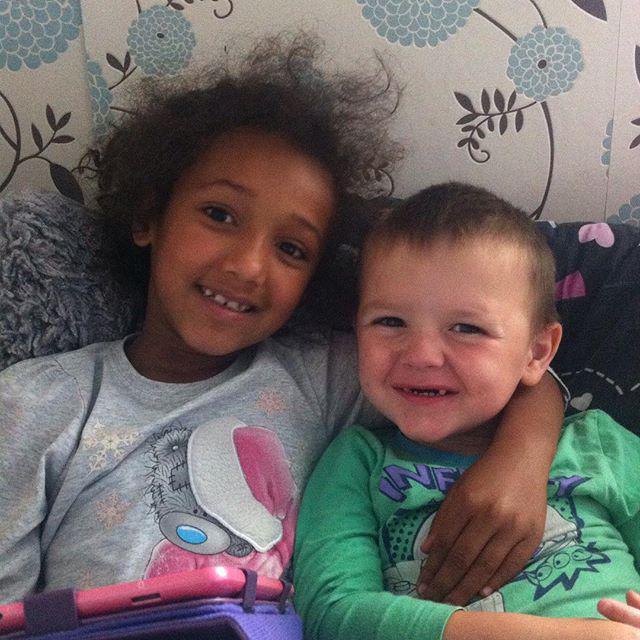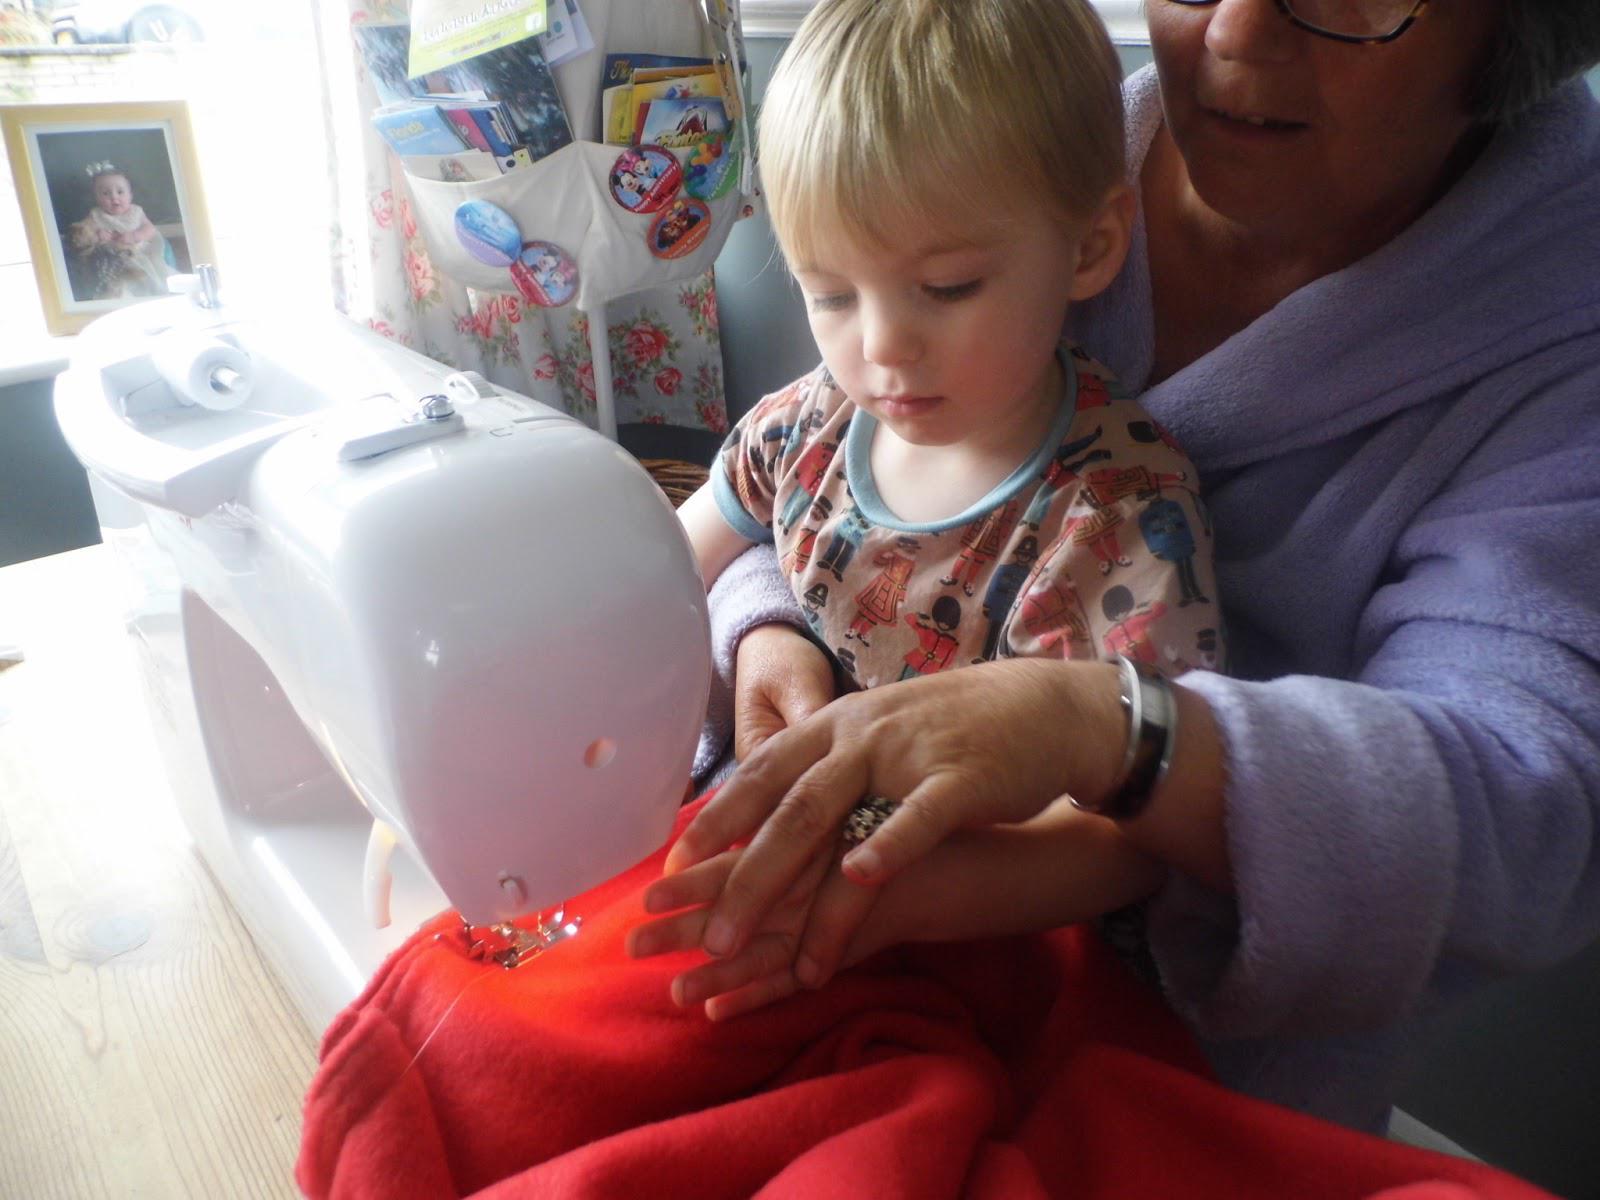The first image is the image on the left, the second image is the image on the right. Evaluate the accuracy of this statement regarding the images: "One image has an adult with a kid in their lap.". Is it true? Answer yes or no. Yes. The first image is the image on the left, the second image is the image on the right. For the images displayed, is the sentence "One of the images has both a boy and a girl." factually correct? Answer yes or no. Yes. 